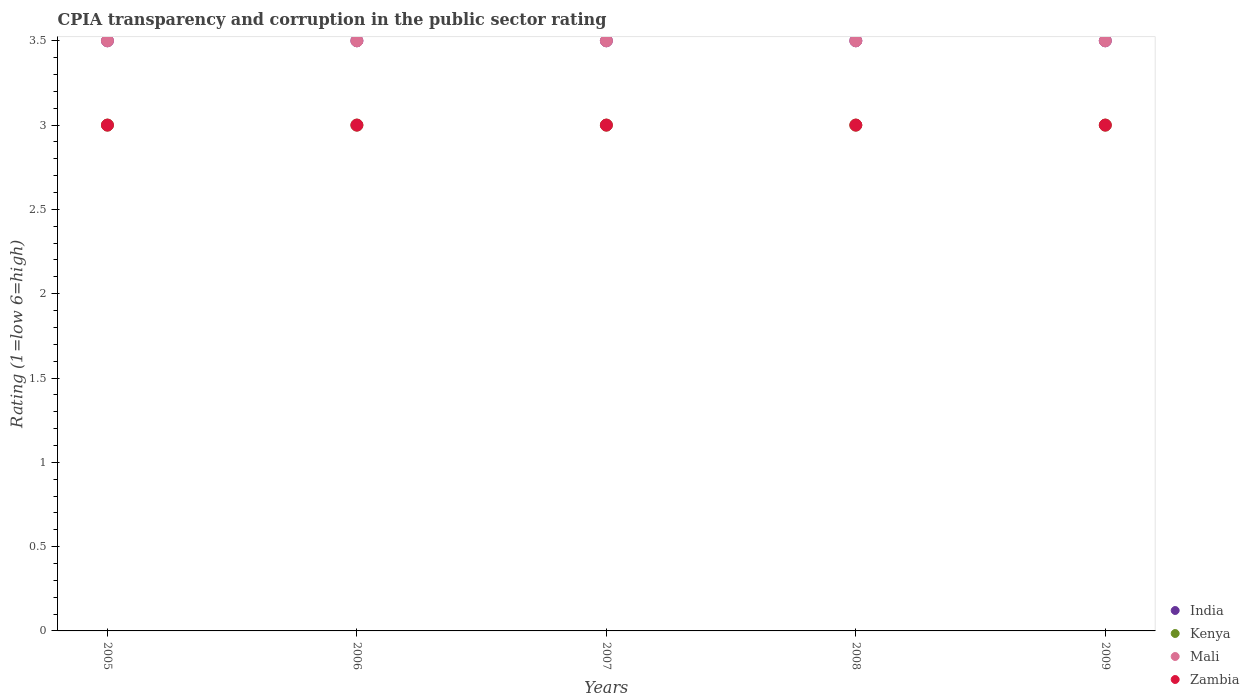What is the CPIA rating in Zambia in 2007?
Your answer should be compact. 3. In which year was the CPIA rating in Kenya minimum?
Provide a succinct answer. 2005. What is the total CPIA rating in India in the graph?
Provide a succinct answer. 17.5. What is the difference between the CPIA rating in Zambia in 2005 and that in 2009?
Your response must be concise. 0. What is the difference between the CPIA rating in India in 2006 and the CPIA rating in Mali in 2005?
Give a very brief answer. 0. In the year 2005, what is the difference between the CPIA rating in Kenya and CPIA rating in Zambia?
Offer a very short reply. 0. In how many years, is the CPIA rating in India greater than 2.8?
Keep it short and to the point. 5. What is the ratio of the CPIA rating in India in 2007 to that in 2008?
Keep it short and to the point. 1. Is the CPIA rating in India in 2005 less than that in 2008?
Your answer should be compact. No. What is the difference between the highest and the lowest CPIA rating in Mali?
Keep it short and to the point. 0. In how many years, is the CPIA rating in India greater than the average CPIA rating in India taken over all years?
Ensure brevity in your answer.  0. Is the sum of the CPIA rating in Kenya in 2005 and 2007 greater than the maximum CPIA rating in India across all years?
Keep it short and to the point. Yes. Is it the case that in every year, the sum of the CPIA rating in India and CPIA rating in Kenya  is greater than the CPIA rating in Mali?
Make the answer very short. Yes. How many dotlines are there?
Your answer should be compact. 4. What is the difference between two consecutive major ticks on the Y-axis?
Make the answer very short. 0.5. Does the graph contain grids?
Keep it short and to the point. No. What is the title of the graph?
Keep it short and to the point. CPIA transparency and corruption in the public sector rating. Does "Syrian Arab Republic" appear as one of the legend labels in the graph?
Your response must be concise. No. What is the label or title of the X-axis?
Offer a very short reply. Years. What is the Rating (1=low 6=high) in India in 2005?
Your response must be concise. 3.5. What is the Rating (1=low 6=high) of Kenya in 2005?
Provide a succinct answer. 3. What is the Rating (1=low 6=high) of Mali in 2005?
Offer a terse response. 3.5. What is the Rating (1=low 6=high) in Mali in 2006?
Ensure brevity in your answer.  3.5. What is the Rating (1=low 6=high) in Zambia in 2006?
Offer a very short reply. 3. What is the Rating (1=low 6=high) in India in 2007?
Your answer should be compact. 3.5. What is the Rating (1=low 6=high) of Kenya in 2007?
Your answer should be compact. 3. What is the Rating (1=low 6=high) of Mali in 2007?
Your response must be concise. 3.5. What is the Rating (1=low 6=high) of India in 2008?
Ensure brevity in your answer.  3.5. What is the Rating (1=low 6=high) in Kenya in 2008?
Make the answer very short. 3. What is the Rating (1=low 6=high) in Mali in 2008?
Make the answer very short. 3.5. What is the Rating (1=low 6=high) of Mali in 2009?
Provide a succinct answer. 3.5. What is the Rating (1=low 6=high) of Zambia in 2009?
Your answer should be very brief. 3. Across all years, what is the minimum Rating (1=low 6=high) of India?
Keep it short and to the point. 3.5. Across all years, what is the minimum Rating (1=low 6=high) of Mali?
Offer a terse response. 3.5. Across all years, what is the minimum Rating (1=low 6=high) of Zambia?
Provide a short and direct response. 3. What is the total Rating (1=low 6=high) of India in the graph?
Your answer should be very brief. 17.5. What is the difference between the Rating (1=low 6=high) in India in 2005 and that in 2006?
Make the answer very short. 0. What is the difference between the Rating (1=low 6=high) in Zambia in 2005 and that in 2006?
Provide a short and direct response. 0. What is the difference between the Rating (1=low 6=high) of India in 2005 and that in 2007?
Give a very brief answer. 0. What is the difference between the Rating (1=low 6=high) of Mali in 2005 and that in 2007?
Your answer should be compact. 0. What is the difference between the Rating (1=low 6=high) of India in 2005 and that in 2008?
Offer a very short reply. 0. What is the difference between the Rating (1=low 6=high) of Kenya in 2005 and that in 2008?
Provide a succinct answer. 0. What is the difference between the Rating (1=low 6=high) in Zambia in 2005 and that in 2008?
Ensure brevity in your answer.  0. What is the difference between the Rating (1=low 6=high) of Kenya in 2005 and that in 2009?
Make the answer very short. 0. What is the difference between the Rating (1=low 6=high) of India in 2006 and that in 2007?
Provide a short and direct response. 0. What is the difference between the Rating (1=low 6=high) in Kenya in 2006 and that in 2007?
Provide a succinct answer. 0. What is the difference between the Rating (1=low 6=high) of India in 2006 and that in 2008?
Your response must be concise. 0. What is the difference between the Rating (1=low 6=high) in Mali in 2006 and that in 2008?
Provide a short and direct response. 0. What is the difference between the Rating (1=low 6=high) in India in 2006 and that in 2009?
Offer a terse response. 0. What is the difference between the Rating (1=low 6=high) in India in 2007 and that in 2008?
Keep it short and to the point. 0. What is the difference between the Rating (1=low 6=high) in Mali in 2007 and that in 2008?
Provide a short and direct response. 0. What is the difference between the Rating (1=low 6=high) in Mali in 2007 and that in 2009?
Keep it short and to the point. 0. What is the difference between the Rating (1=low 6=high) in Zambia in 2007 and that in 2009?
Offer a terse response. 0. What is the difference between the Rating (1=low 6=high) of Kenya in 2008 and that in 2009?
Give a very brief answer. 0. What is the difference between the Rating (1=low 6=high) of Mali in 2008 and that in 2009?
Give a very brief answer. 0. What is the difference between the Rating (1=low 6=high) of Kenya in 2005 and the Rating (1=low 6=high) of Zambia in 2006?
Offer a terse response. 0. What is the difference between the Rating (1=low 6=high) in Mali in 2005 and the Rating (1=low 6=high) in Zambia in 2006?
Provide a short and direct response. 0.5. What is the difference between the Rating (1=low 6=high) of India in 2005 and the Rating (1=low 6=high) of Mali in 2007?
Offer a very short reply. 0. What is the difference between the Rating (1=low 6=high) of India in 2005 and the Rating (1=low 6=high) of Zambia in 2007?
Ensure brevity in your answer.  0.5. What is the difference between the Rating (1=low 6=high) in India in 2005 and the Rating (1=low 6=high) in Mali in 2008?
Give a very brief answer. 0. What is the difference between the Rating (1=low 6=high) of India in 2005 and the Rating (1=low 6=high) of Mali in 2009?
Offer a terse response. 0. What is the difference between the Rating (1=low 6=high) of India in 2005 and the Rating (1=low 6=high) of Zambia in 2009?
Keep it short and to the point. 0.5. What is the difference between the Rating (1=low 6=high) of Kenya in 2005 and the Rating (1=low 6=high) of Mali in 2009?
Provide a succinct answer. -0.5. What is the difference between the Rating (1=low 6=high) of Kenya in 2005 and the Rating (1=low 6=high) of Zambia in 2009?
Provide a short and direct response. 0. What is the difference between the Rating (1=low 6=high) of Kenya in 2006 and the Rating (1=low 6=high) of Zambia in 2007?
Your answer should be compact. 0. What is the difference between the Rating (1=low 6=high) in India in 2006 and the Rating (1=low 6=high) in Kenya in 2008?
Your response must be concise. 0.5. What is the difference between the Rating (1=low 6=high) in Kenya in 2006 and the Rating (1=low 6=high) in Zambia in 2008?
Make the answer very short. 0. What is the difference between the Rating (1=low 6=high) of Mali in 2006 and the Rating (1=low 6=high) of Zambia in 2008?
Your response must be concise. 0.5. What is the difference between the Rating (1=low 6=high) in India in 2006 and the Rating (1=low 6=high) in Mali in 2009?
Ensure brevity in your answer.  0. What is the difference between the Rating (1=low 6=high) in India in 2006 and the Rating (1=low 6=high) in Zambia in 2009?
Your answer should be compact. 0.5. What is the difference between the Rating (1=low 6=high) in Kenya in 2006 and the Rating (1=low 6=high) in Zambia in 2009?
Provide a short and direct response. 0. What is the difference between the Rating (1=low 6=high) in India in 2007 and the Rating (1=low 6=high) in Kenya in 2008?
Give a very brief answer. 0.5. What is the difference between the Rating (1=low 6=high) in Kenya in 2007 and the Rating (1=low 6=high) in Mali in 2008?
Offer a very short reply. -0.5. What is the difference between the Rating (1=low 6=high) of Kenya in 2007 and the Rating (1=low 6=high) of Zambia in 2008?
Your response must be concise. 0. What is the difference between the Rating (1=low 6=high) of India in 2007 and the Rating (1=low 6=high) of Kenya in 2009?
Your response must be concise. 0.5. What is the difference between the Rating (1=low 6=high) in India in 2007 and the Rating (1=low 6=high) in Zambia in 2009?
Make the answer very short. 0.5. What is the difference between the Rating (1=low 6=high) of Mali in 2007 and the Rating (1=low 6=high) of Zambia in 2009?
Your response must be concise. 0.5. What is the difference between the Rating (1=low 6=high) in India in 2008 and the Rating (1=low 6=high) in Kenya in 2009?
Make the answer very short. 0.5. What is the difference between the Rating (1=low 6=high) in India in 2008 and the Rating (1=low 6=high) in Zambia in 2009?
Your answer should be very brief. 0.5. What is the difference between the Rating (1=low 6=high) of Kenya in 2008 and the Rating (1=low 6=high) of Mali in 2009?
Your answer should be very brief. -0.5. What is the difference between the Rating (1=low 6=high) of Kenya in 2008 and the Rating (1=low 6=high) of Zambia in 2009?
Your answer should be compact. 0. What is the difference between the Rating (1=low 6=high) in Mali in 2008 and the Rating (1=low 6=high) in Zambia in 2009?
Your answer should be very brief. 0.5. What is the average Rating (1=low 6=high) in Mali per year?
Offer a terse response. 3.5. In the year 2005, what is the difference between the Rating (1=low 6=high) in India and Rating (1=low 6=high) in Zambia?
Keep it short and to the point. 0.5. In the year 2005, what is the difference between the Rating (1=low 6=high) in Kenya and Rating (1=low 6=high) in Mali?
Provide a succinct answer. -0.5. In the year 2006, what is the difference between the Rating (1=low 6=high) in India and Rating (1=low 6=high) in Kenya?
Ensure brevity in your answer.  0.5. In the year 2006, what is the difference between the Rating (1=low 6=high) of India and Rating (1=low 6=high) of Mali?
Your answer should be compact. 0. In the year 2006, what is the difference between the Rating (1=low 6=high) in Kenya and Rating (1=low 6=high) in Zambia?
Give a very brief answer. 0. In the year 2006, what is the difference between the Rating (1=low 6=high) of Mali and Rating (1=low 6=high) of Zambia?
Your answer should be very brief. 0.5. In the year 2007, what is the difference between the Rating (1=low 6=high) of India and Rating (1=low 6=high) of Kenya?
Your answer should be very brief. 0.5. In the year 2007, what is the difference between the Rating (1=low 6=high) of India and Rating (1=low 6=high) of Mali?
Your answer should be very brief. 0. In the year 2007, what is the difference between the Rating (1=low 6=high) of India and Rating (1=low 6=high) of Zambia?
Make the answer very short. 0.5. In the year 2007, what is the difference between the Rating (1=low 6=high) of Kenya and Rating (1=low 6=high) of Mali?
Your response must be concise. -0.5. In the year 2007, what is the difference between the Rating (1=low 6=high) of Kenya and Rating (1=low 6=high) of Zambia?
Ensure brevity in your answer.  0. In the year 2007, what is the difference between the Rating (1=low 6=high) in Mali and Rating (1=low 6=high) in Zambia?
Your response must be concise. 0.5. In the year 2008, what is the difference between the Rating (1=low 6=high) of India and Rating (1=low 6=high) of Zambia?
Offer a terse response. 0.5. In the year 2008, what is the difference between the Rating (1=low 6=high) in Kenya and Rating (1=low 6=high) in Mali?
Offer a very short reply. -0.5. In the year 2009, what is the difference between the Rating (1=low 6=high) in India and Rating (1=low 6=high) in Kenya?
Give a very brief answer. 0.5. In the year 2009, what is the difference between the Rating (1=low 6=high) in Kenya and Rating (1=low 6=high) in Mali?
Your answer should be very brief. -0.5. What is the ratio of the Rating (1=low 6=high) of India in 2005 to that in 2006?
Make the answer very short. 1. What is the ratio of the Rating (1=low 6=high) in Kenya in 2005 to that in 2006?
Offer a terse response. 1. What is the ratio of the Rating (1=low 6=high) of Kenya in 2005 to that in 2008?
Provide a short and direct response. 1. What is the ratio of the Rating (1=low 6=high) of Mali in 2005 to that in 2008?
Provide a short and direct response. 1. What is the ratio of the Rating (1=low 6=high) in India in 2005 to that in 2009?
Provide a succinct answer. 1. What is the ratio of the Rating (1=low 6=high) in Mali in 2005 to that in 2009?
Ensure brevity in your answer.  1. What is the ratio of the Rating (1=low 6=high) of India in 2006 to that in 2007?
Your answer should be very brief. 1. What is the ratio of the Rating (1=low 6=high) in Kenya in 2006 to that in 2007?
Keep it short and to the point. 1. What is the ratio of the Rating (1=low 6=high) of Mali in 2006 to that in 2007?
Your answer should be compact. 1. What is the ratio of the Rating (1=low 6=high) of India in 2006 to that in 2008?
Provide a short and direct response. 1. What is the ratio of the Rating (1=low 6=high) of Mali in 2006 to that in 2008?
Ensure brevity in your answer.  1. What is the ratio of the Rating (1=low 6=high) of India in 2006 to that in 2009?
Make the answer very short. 1. What is the ratio of the Rating (1=low 6=high) of Zambia in 2006 to that in 2009?
Provide a succinct answer. 1. What is the ratio of the Rating (1=low 6=high) of India in 2007 to that in 2008?
Offer a terse response. 1. What is the ratio of the Rating (1=low 6=high) in Kenya in 2007 to that in 2008?
Provide a succinct answer. 1. What is the ratio of the Rating (1=low 6=high) of Mali in 2007 to that in 2008?
Provide a short and direct response. 1. What is the ratio of the Rating (1=low 6=high) in India in 2007 to that in 2009?
Your answer should be very brief. 1. What is the ratio of the Rating (1=low 6=high) of Kenya in 2007 to that in 2009?
Give a very brief answer. 1. What is the ratio of the Rating (1=low 6=high) of Mali in 2007 to that in 2009?
Your answer should be compact. 1. What is the ratio of the Rating (1=low 6=high) of Zambia in 2007 to that in 2009?
Provide a short and direct response. 1. What is the ratio of the Rating (1=low 6=high) of Mali in 2008 to that in 2009?
Provide a short and direct response. 1. What is the difference between the highest and the lowest Rating (1=low 6=high) of Kenya?
Your response must be concise. 0. What is the difference between the highest and the lowest Rating (1=low 6=high) of Mali?
Keep it short and to the point. 0. 